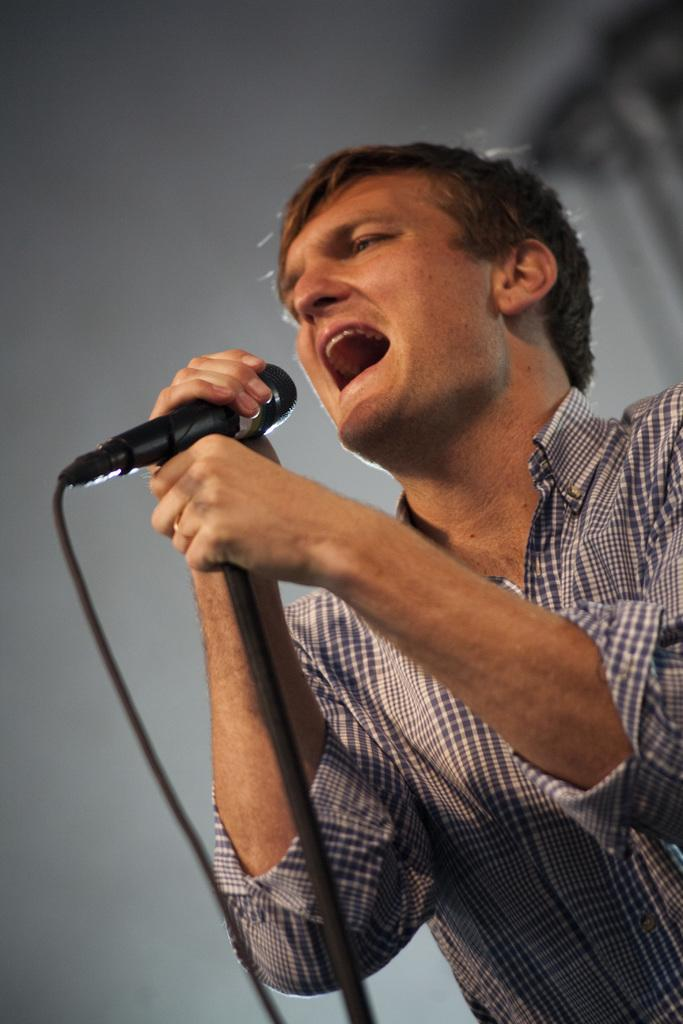Who is the main subject in the image? There is a man in the image. Where is the man located in the image? The man is standing on the bottom right side of the image. What is the man holding in the image? The man is holding a microphone. What is the man doing in the image? The man is singing. Is there a volcano erupting in the background of the image? No, there is no volcano present in the image. What is the man's digestive system doing while he is singing? The image does not provide information about the man's digestive system, so it cannot be determined from the image. 